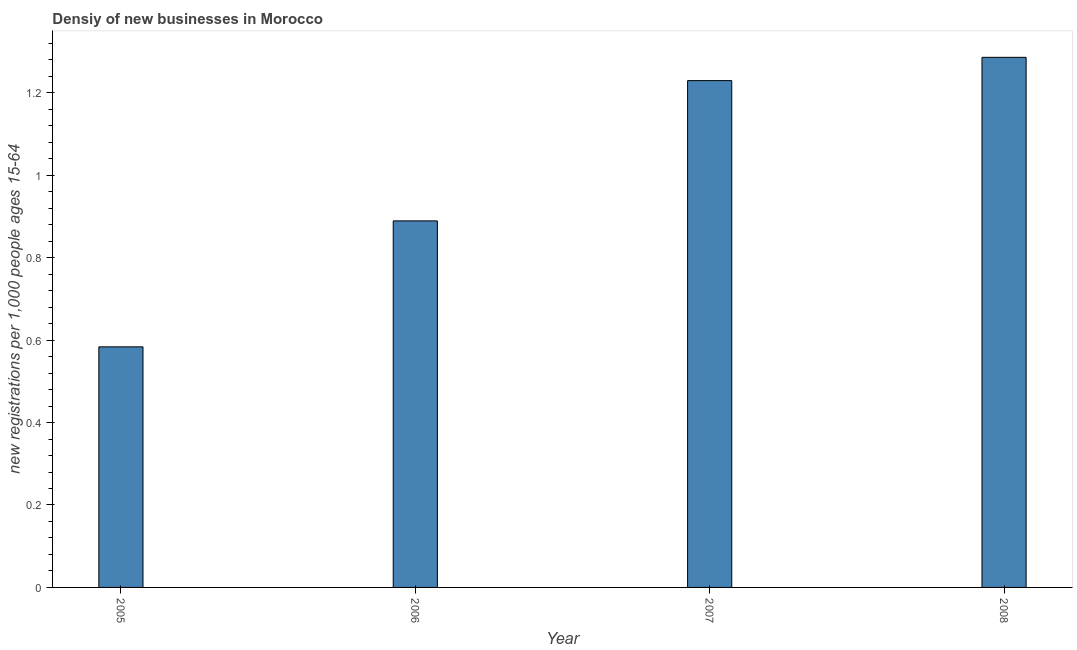What is the title of the graph?
Provide a succinct answer. Densiy of new businesses in Morocco. What is the label or title of the X-axis?
Your answer should be compact. Year. What is the label or title of the Y-axis?
Keep it short and to the point. New registrations per 1,0 people ages 15-64. What is the density of new business in 2005?
Provide a short and direct response. 0.58. Across all years, what is the maximum density of new business?
Offer a very short reply. 1.29. Across all years, what is the minimum density of new business?
Your response must be concise. 0.58. In which year was the density of new business maximum?
Provide a succinct answer. 2008. In which year was the density of new business minimum?
Offer a terse response. 2005. What is the sum of the density of new business?
Give a very brief answer. 3.99. What is the difference between the density of new business in 2007 and 2008?
Offer a terse response. -0.06. What is the average density of new business per year?
Keep it short and to the point. 1. What is the median density of new business?
Ensure brevity in your answer.  1.06. In how many years, is the density of new business greater than 0.92 ?
Your answer should be compact. 2. What is the ratio of the density of new business in 2005 to that in 2006?
Offer a very short reply. 0.66. What is the difference between the highest and the second highest density of new business?
Your answer should be very brief. 0.06. Is the sum of the density of new business in 2005 and 2006 greater than the maximum density of new business across all years?
Your response must be concise. Yes. In how many years, is the density of new business greater than the average density of new business taken over all years?
Provide a short and direct response. 2. How many bars are there?
Ensure brevity in your answer.  4. What is the difference between two consecutive major ticks on the Y-axis?
Give a very brief answer. 0.2. What is the new registrations per 1,000 people ages 15-64 of 2005?
Your answer should be very brief. 0.58. What is the new registrations per 1,000 people ages 15-64 of 2006?
Provide a succinct answer. 0.89. What is the new registrations per 1,000 people ages 15-64 of 2007?
Give a very brief answer. 1.23. What is the new registrations per 1,000 people ages 15-64 in 2008?
Keep it short and to the point. 1.29. What is the difference between the new registrations per 1,000 people ages 15-64 in 2005 and 2006?
Provide a short and direct response. -0.31. What is the difference between the new registrations per 1,000 people ages 15-64 in 2005 and 2007?
Your answer should be very brief. -0.65. What is the difference between the new registrations per 1,000 people ages 15-64 in 2005 and 2008?
Give a very brief answer. -0.7. What is the difference between the new registrations per 1,000 people ages 15-64 in 2006 and 2007?
Provide a succinct answer. -0.34. What is the difference between the new registrations per 1,000 people ages 15-64 in 2006 and 2008?
Keep it short and to the point. -0.4. What is the difference between the new registrations per 1,000 people ages 15-64 in 2007 and 2008?
Ensure brevity in your answer.  -0.06. What is the ratio of the new registrations per 1,000 people ages 15-64 in 2005 to that in 2006?
Make the answer very short. 0.66. What is the ratio of the new registrations per 1,000 people ages 15-64 in 2005 to that in 2007?
Give a very brief answer. 0.47. What is the ratio of the new registrations per 1,000 people ages 15-64 in 2005 to that in 2008?
Offer a terse response. 0.45. What is the ratio of the new registrations per 1,000 people ages 15-64 in 2006 to that in 2007?
Your answer should be very brief. 0.72. What is the ratio of the new registrations per 1,000 people ages 15-64 in 2006 to that in 2008?
Provide a succinct answer. 0.69. What is the ratio of the new registrations per 1,000 people ages 15-64 in 2007 to that in 2008?
Your answer should be very brief. 0.96. 